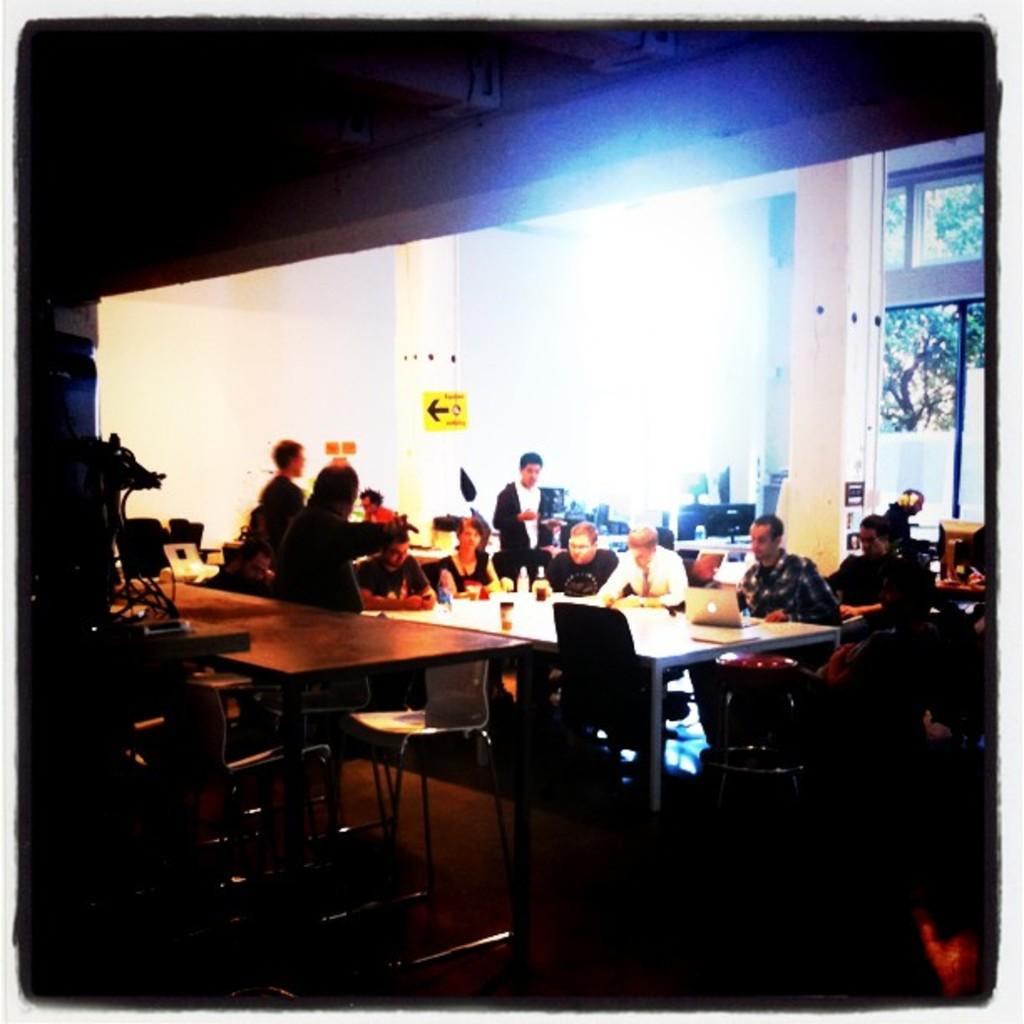Can you describe this image briefly? In this image I can see few people are sitting on the chairs in front of the table on which laptops, few glasses are placed. In the background there are two pillars. On the bottom of the image I can see some empty chairs. 